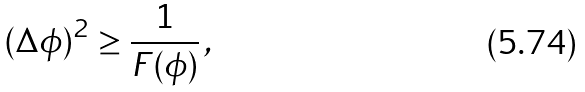<formula> <loc_0><loc_0><loc_500><loc_500>( \Delta \phi ) ^ { 2 } \geq \frac { 1 } { F ( \phi ) } \, ,</formula> 